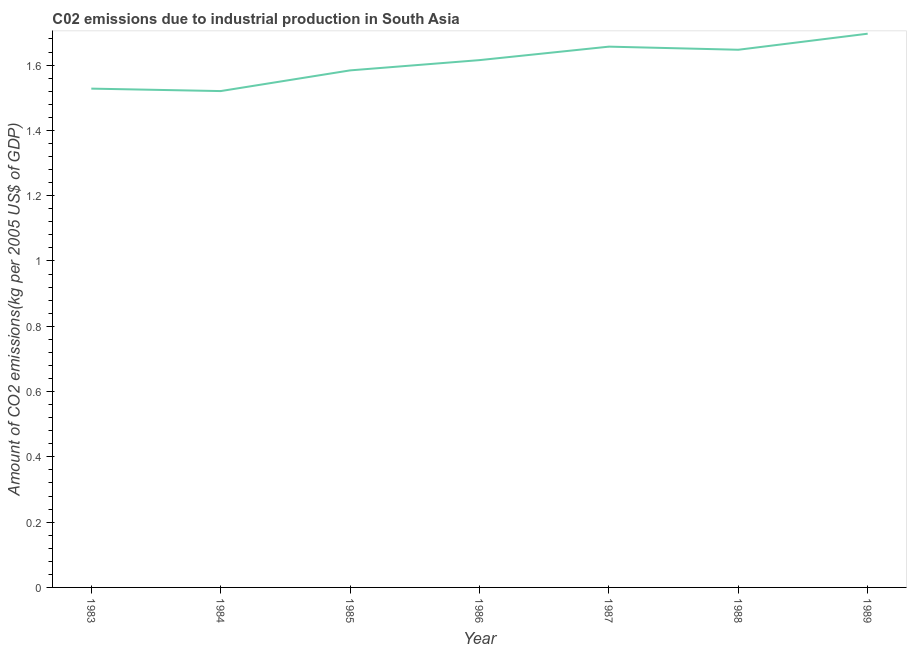What is the amount of co2 emissions in 1985?
Provide a short and direct response. 1.58. Across all years, what is the maximum amount of co2 emissions?
Offer a very short reply. 1.7. Across all years, what is the minimum amount of co2 emissions?
Give a very brief answer. 1.52. In which year was the amount of co2 emissions maximum?
Provide a succinct answer. 1989. What is the sum of the amount of co2 emissions?
Your answer should be compact. 11.25. What is the difference between the amount of co2 emissions in 1984 and 1986?
Your response must be concise. -0.09. What is the average amount of co2 emissions per year?
Offer a very short reply. 1.61. What is the median amount of co2 emissions?
Your answer should be compact. 1.62. In how many years, is the amount of co2 emissions greater than 0.88 kg per 2005 US$ of GDP?
Your response must be concise. 7. Do a majority of the years between 1986 and 1985 (inclusive) have amount of co2 emissions greater than 0.44 kg per 2005 US$ of GDP?
Your answer should be compact. No. What is the ratio of the amount of co2 emissions in 1985 to that in 1988?
Ensure brevity in your answer.  0.96. Is the difference between the amount of co2 emissions in 1984 and 1989 greater than the difference between any two years?
Your answer should be compact. Yes. What is the difference between the highest and the second highest amount of co2 emissions?
Your answer should be very brief. 0.04. Is the sum of the amount of co2 emissions in 1985 and 1988 greater than the maximum amount of co2 emissions across all years?
Offer a very short reply. Yes. What is the difference between the highest and the lowest amount of co2 emissions?
Offer a very short reply. 0.18. In how many years, is the amount of co2 emissions greater than the average amount of co2 emissions taken over all years?
Keep it short and to the point. 4. Does the amount of co2 emissions monotonically increase over the years?
Your answer should be very brief. No. How many lines are there?
Keep it short and to the point. 1. What is the difference between two consecutive major ticks on the Y-axis?
Offer a very short reply. 0.2. Does the graph contain grids?
Provide a short and direct response. No. What is the title of the graph?
Your answer should be compact. C02 emissions due to industrial production in South Asia. What is the label or title of the X-axis?
Ensure brevity in your answer.  Year. What is the label or title of the Y-axis?
Give a very brief answer. Amount of CO2 emissions(kg per 2005 US$ of GDP). What is the Amount of CO2 emissions(kg per 2005 US$ of GDP) of 1983?
Make the answer very short. 1.53. What is the Amount of CO2 emissions(kg per 2005 US$ of GDP) of 1984?
Provide a short and direct response. 1.52. What is the Amount of CO2 emissions(kg per 2005 US$ of GDP) of 1985?
Provide a short and direct response. 1.58. What is the Amount of CO2 emissions(kg per 2005 US$ of GDP) of 1986?
Keep it short and to the point. 1.62. What is the Amount of CO2 emissions(kg per 2005 US$ of GDP) in 1987?
Keep it short and to the point. 1.66. What is the Amount of CO2 emissions(kg per 2005 US$ of GDP) of 1988?
Provide a succinct answer. 1.65. What is the Amount of CO2 emissions(kg per 2005 US$ of GDP) of 1989?
Offer a terse response. 1.7. What is the difference between the Amount of CO2 emissions(kg per 2005 US$ of GDP) in 1983 and 1984?
Make the answer very short. 0.01. What is the difference between the Amount of CO2 emissions(kg per 2005 US$ of GDP) in 1983 and 1985?
Give a very brief answer. -0.06. What is the difference between the Amount of CO2 emissions(kg per 2005 US$ of GDP) in 1983 and 1986?
Your answer should be compact. -0.09. What is the difference between the Amount of CO2 emissions(kg per 2005 US$ of GDP) in 1983 and 1987?
Your answer should be very brief. -0.13. What is the difference between the Amount of CO2 emissions(kg per 2005 US$ of GDP) in 1983 and 1988?
Ensure brevity in your answer.  -0.12. What is the difference between the Amount of CO2 emissions(kg per 2005 US$ of GDP) in 1983 and 1989?
Keep it short and to the point. -0.17. What is the difference between the Amount of CO2 emissions(kg per 2005 US$ of GDP) in 1984 and 1985?
Ensure brevity in your answer.  -0.06. What is the difference between the Amount of CO2 emissions(kg per 2005 US$ of GDP) in 1984 and 1986?
Your response must be concise. -0.09. What is the difference between the Amount of CO2 emissions(kg per 2005 US$ of GDP) in 1984 and 1987?
Your answer should be very brief. -0.14. What is the difference between the Amount of CO2 emissions(kg per 2005 US$ of GDP) in 1984 and 1988?
Offer a terse response. -0.13. What is the difference between the Amount of CO2 emissions(kg per 2005 US$ of GDP) in 1984 and 1989?
Provide a short and direct response. -0.18. What is the difference between the Amount of CO2 emissions(kg per 2005 US$ of GDP) in 1985 and 1986?
Your answer should be very brief. -0.03. What is the difference between the Amount of CO2 emissions(kg per 2005 US$ of GDP) in 1985 and 1987?
Ensure brevity in your answer.  -0.07. What is the difference between the Amount of CO2 emissions(kg per 2005 US$ of GDP) in 1985 and 1988?
Provide a short and direct response. -0.06. What is the difference between the Amount of CO2 emissions(kg per 2005 US$ of GDP) in 1985 and 1989?
Keep it short and to the point. -0.11. What is the difference between the Amount of CO2 emissions(kg per 2005 US$ of GDP) in 1986 and 1987?
Your answer should be compact. -0.04. What is the difference between the Amount of CO2 emissions(kg per 2005 US$ of GDP) in 1986 and 1988?
Your response must be concise. -0.03. What is the difference between the Amount of CO2 emissions(kg per 2005 US$ of GDP) in 1986 and 1989?
Offer a terse response. -0.08. What is the difference between the Amount of CO2 emissions(kg per 2005 US$ of GDP) in 1987 and 1988?
Provide a succinct answer. 0.01. What is the difference between the Amount of CO2 emissions(kg per 2005 US$ of GDP) in 1987 and 1989?
Your answer should be very brief. -0.04. What is the difference between the Amount of CO2 emissions(kg per 2005 US$ of GDP) in 1988 and 1989?
Provide a short and direct response. -0.05. What is the ratio of the Amount of CO2 emissions(kg per 2005 US$ of GDP) in 1983 to that in 1984?
Keep it short and to the point. 1. What is the ratio of the Amount of CO2 emissions(kg per 2005 US$ of GDP) in 1983 to that in 1985?
Offer a very short reply. 0.96. What is the ratio of the Amount of CO2 emissions(kg per 2005 US$ of GDP) in 1983 to that in 1986?
Give a very brief answer. 0.95. What is the ratio of the Amount of CO2 emissions(kg per 2005 US$ of GDP) in 1983 to that in 1987?
Make the answer very short. 0.92. What is the ratio of the Amount of CO2 emissions(kg per 2005 US$ of GDP) in 1983 to that in 1988?
Your answer should be very brief. 0.93. What is the ratio of the Amount of CO2 emissions(kg per 2005 US$ of GDP) in 1983 to that in 1989?
Ensure brevity in your answer.  0.9. What is the ratio of the Amount of CO2 emissions(kg per 2005 US$ of GDP) in 1984 to that in 1986?
Your answer should be compact. 0.94. What is the ratio of the Amount of CO2 emissions(kg per 2005 US$ of GDP) in 1984 to that in 1987?
Keep it short and to the point. 0.92. What is the ratio of the Amount of CO2 emissions(kg per 2005 US$ of GDP) in 1984 to that in 1988?
Offer a very short reply. 0.92. What is the ratio of the Amount of CO2 emissions(kg per 2005 US$ of GDP) in 1984 to that in 1989?
Provide a short and direct response. 0.9. What is the ratio of the Amount of CO2 emissions(kg per 2005 US$ of GDP) in 1985 to that in 1987?
Provide a succinct answer. 0.96. What is the ratio of the Amount of CO2 emissions(kg per 2005 US$ of GDP) in 1985 to that in 1988?
Give a very brief answer. 0.96. What is the ratio of the Amount of CO2 emissions(kg per 2005 US$ of GDP) in 1985 to that in 1989?
Give a very brief answer. 0.93. What is the ratio of the Amount of CO2 emissions(kg per 2005 US$ of GDP) in 1986 to that in 1988?
Provide a succinct answer. 0.98. 